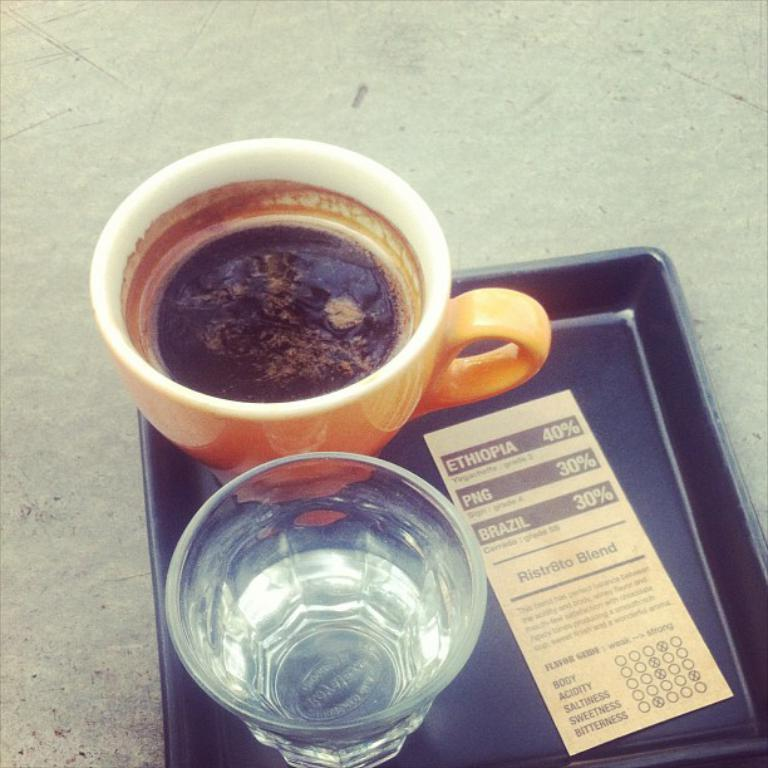What material is present in the image? There is glass in the image. What type of container is visible in the image? There is a cup in the image. What is the object used for holding multiple items in the image? There is a tray in the image. What type of writing surface is present in the image? There is paper in the image. What liquid is visible in the image? There is water in the image. What type of beverage is present in the image? There is a drink in the image. What type of curtain is hanging in the image? There is no curtain present in the image. How many fingers can be seen holding the glass in the image? There are no fingers visible in the image; only the glass, cup, tray, paper, water, and drink are present. 